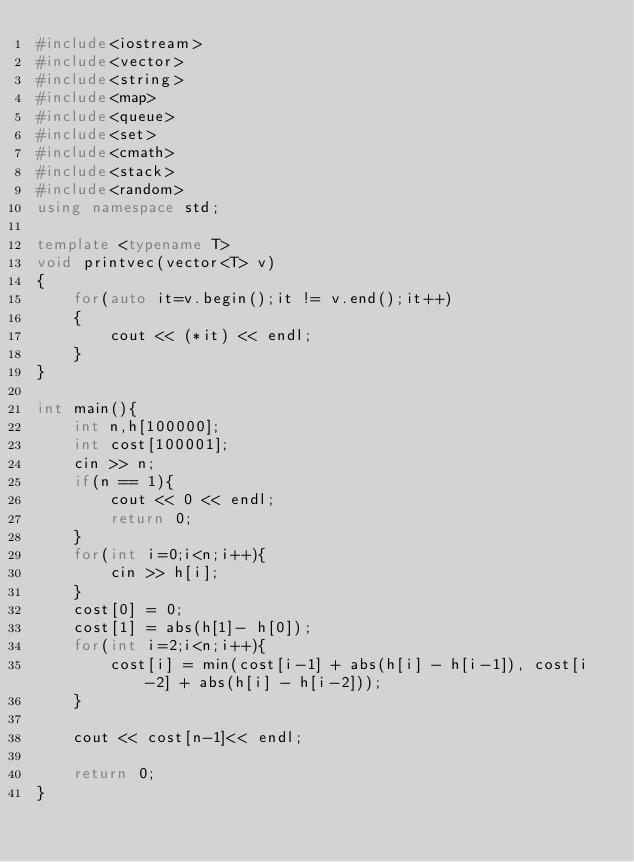Convert code to text. <code><loc_0><loc_0><loc_500><loc_500><_C++_>#include<iostream>
#include<vector>
#include<string>
#include<map>
#include<queue>
#include<set>
#include<cmath>
#include<stack>
#include<random>
using namespace std;

template <typename T>
void printvec(vector<T> v)
{
    for(auto it=v.begin();it != v.end();it++)
    {
        cout << (*it) << endl;
    }
}

int main(){
    int n,h[100000];
    int cost[100001];
    cin >> n;
    if(n == 1){
        cout << 0 << endl;
        return 0;
    }
    for(int i=0;i<n;i++){
        cin >> h[i];
    }
    cost[0] = 0;
    cost[1] = abs(h[1]- h[0]);
    for(int i=2;i<n;i++){
        cost[i] = min(cost[i-1] + abs(h[i] - h[i-1]), cost[i-2] + abs(h[i] - h[i-2]));
    }

    cout << cost[n-1]<< endl;

    return 0;
}</code> 